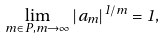Convert formula to latex. <formula><loc_0><loc_0><loc_500><loc_500>\lim _ { m \in P , m \to \infty } | a _ { m } | ^ { 1 / m } = 1 ,</formula> 